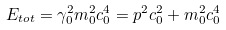<formula> <loc_0><loc_0><loc_500><loc_500>E _ { t o t } = \gamma _ { 0 } ^ { 2 } m _ { 0 } ^ { 2 } c _ { 0 } ^ { 4 } = p ^ { 2 } c _ { 0 } ^ { 2 } + m _ { 0 } ^ { 2 } c _ { 0 } ^ { 4 }</formula> 